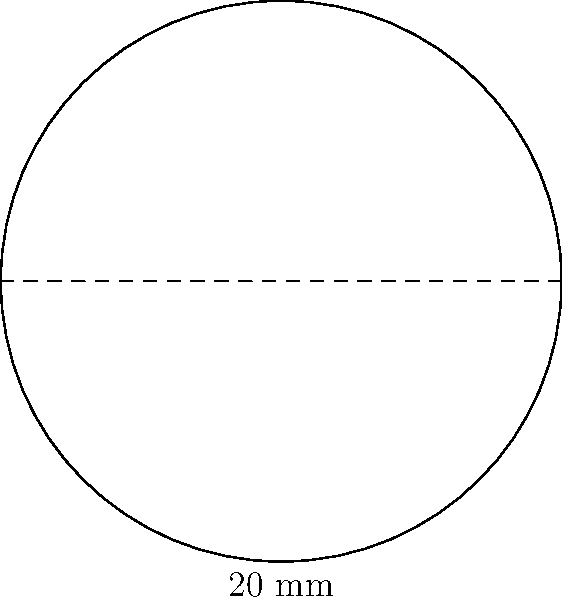As part of an initiative to improve vision care affordability, you're reviewing a proposal for a new contact lens manufacturing process. The process creates circular lenses with a diameter of 20 mm. Calculate the area of each lens in square millimeters. Use $\pi = 3.14$ for your calculations. To calculate the area of a circular lens, we need to follow these steps:

1) Recall the formula for the area of a circle: $A = \pi r^2$, where $r$ is the radius.

2) We're given the diameter (20 mm), but we need the radius. The radius is half the diameter:
   $r = \frac{20}{2} = 10$ mm

3) Now we can substitute this into our formula, using $\pi = 3.14$:
   $A = \pi r^2 = 3.14 \times 10^2$

4) Calculate:
   $A = 3.14 \times 100 = 314$ mm²

Therefore, the area of each lens is 314 square millimeters.
Answer: 314 mm² 